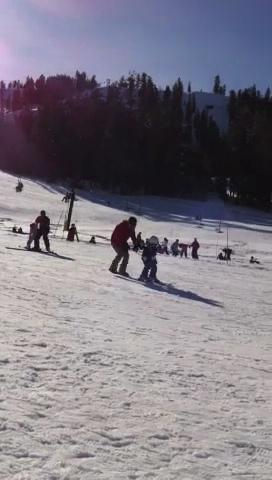Question: where is this picture taken?
Choices:
A. At home.
B. On a ski slope.
C. On the beach.
D. In the mall.
Answer with the letter. Answer: B Question: what is on the ground?
Choices:
A. Insects.
B. Dirt.
C. Grass.
D. Snow.
Answer with the letter. Answer: D Question: what color is the snow?
Choices:
A. Cream.
B. White.
C. Brown.
D. Yellow.
Answer with the letter. Answer: B Question: how is the weather?
Choices:
A. Rainy.
B. Cold.
C. Humid.
D. Sunny.
Answer with the letter. Answer: D Question: what is the child wearing on her feet?
Choices:
A. Skis.
B. Sandals.
C. Shoes.
D. Socks.
Answer with the letter. Answer: A Question: what sport is featured?
Choices:
A. Skiing.
B. Volleyball.
C. Basketball.
D. Football.
Answer with the letter. Answer: A Question: what plant is growing on the mountains?
Choices:
A. Bushes.
B. Grass.
C. Small trees.
D. Pine trees.
Answer with the letter. Answer: D 